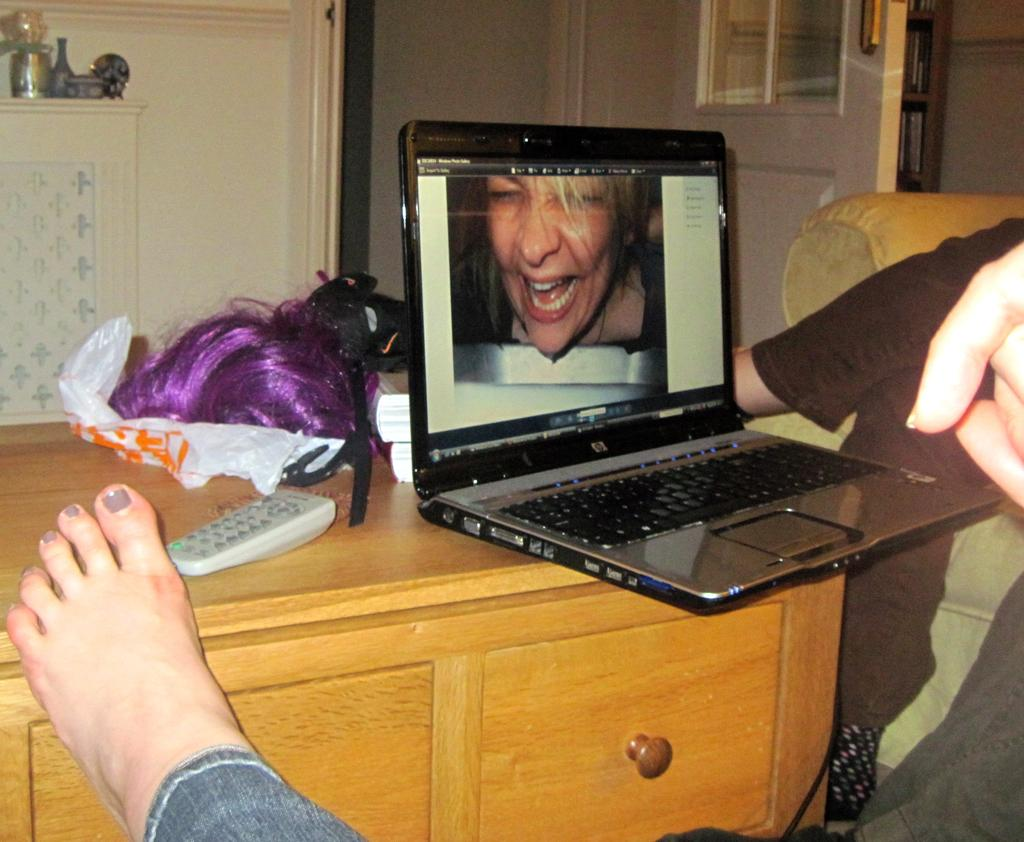What electronic device is on the table in the image? There is a laptop on a table in the image. Can you describe any other objects or body parts visible in the image? A leg of a woman is visible in the image. What type of toothbrush is the woman using in the image? There is no toothbrush present in the image. Is the woman holding a receipt in the image? There is no receipt visible in the image. 